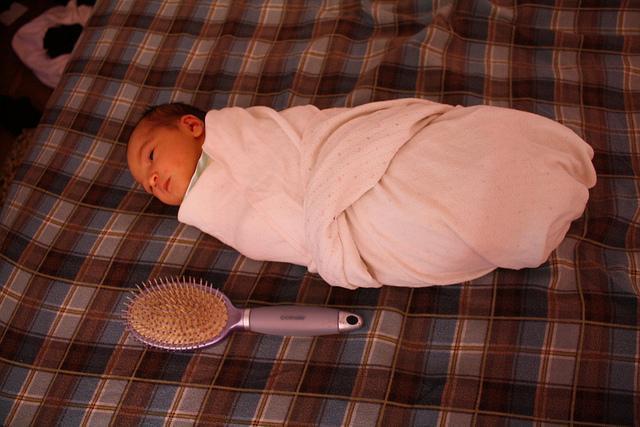How many white remotes do you see?
Give a very brief answer. 0. 